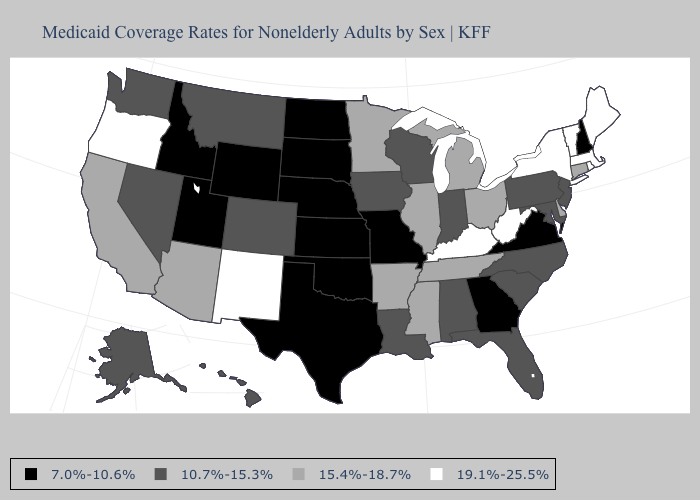Name the states that have a value in the range 10.7%-15.3%?
Be succinct. Alabama, Alaska, Colorado, Florida, Hawaii, Indiana, Iowa, Louisiana, Maryland, Montana, Nevada, New Jersey, North Carolina, Pennsylvania, South Carolina, Washington, Wisconsin. Does New York have the highest value in the USA?
Be succinct. Yes. Does Utah have the lowest value in the West?
Answer briefly. Yes. What is the value of Louisiana?
Quick response, please. 10.7%-15.3%. Does Louisiana have the lowest value in the South?
Write a very short answer. No. Does New Hampshire have the lowest value in the Northeast?
Answer briefly. Yes. Name the states that have a value in the range 19.1%-25.5%?
Answer briefly. Kentucky, Maine, Massachusetts, New Mexico, New York, Oregon, Rhode Island, Vermont, West Virginia. Does Illinois have the same value as Connecticut?
Concise answer only. Yes. What is the highest value in the Northeast ?
Give a very brief answer. 19.1%-25.5%. Name the states that have a value in the range 7.0%-10.6%?
Write a very short answer. Georgia, Idaho, Kansas, Missouri, Nebraska, New Hampshire, North Dakota, Oklahoma, South Dakota, Texas, Utah, Virginia, Wyoming. How many symbols are there in the legend?
Give a very brief answer. 4. What is the value of Nebraska?
Write a very short answer. 7.0%-10.6%. What is the value of Oregon?
Short answer required. 19.1%-25.5%. What is the lowest value in the USA?
Write a very short answer. 7.0%-10.6%. Is the legend a continuous bar?
Concise answer only. No. 